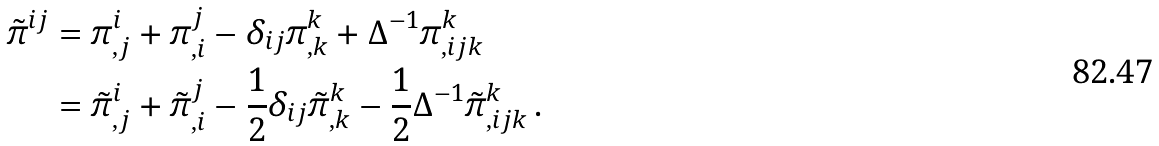<formula> <loc_0><loc_0><loc_500><loc_500>\tilde { \pi } ^ { i j } & = \pi ^ { i } _ { , j } + \pi ^ { j } _ { , i } - \delta _ { i j } \pi ^ { k } _ { , k } + \Delta ^ { - 1 } \pi ^ { k } _ { , i j k } \\ & = \tilde { \pi } ^ { i } _ { , j } + \tilde { \pi } ^ { j } _ { , i } - \frac { 1 } { 2 } \delta _ { i j } \tilde { \pi } ^ { k } _ { , k } - \frac { 1 } { 2 } \Delta ^ { - 1 } \tilde { \pi } ^ { k } _ { , i j k } \, .</formula> 